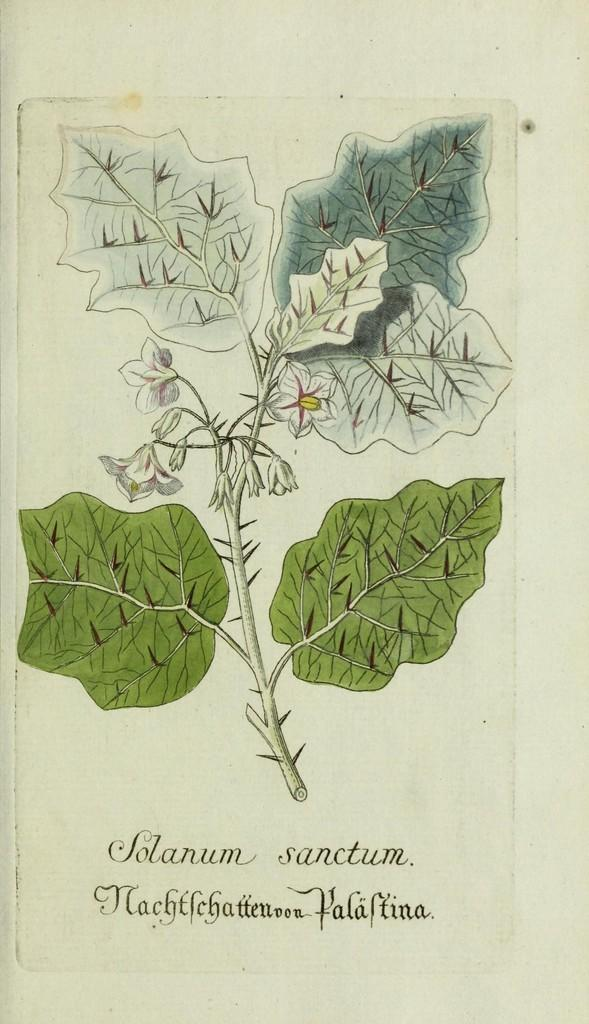What is featured on the poster in the image? The poster contains images of leaves and flowers. Is there any text on the poster? Yes, there is text on the poster. What type of badge is pinned to the throat of the person in the image? There is no person present in the image, and therefore no badge can be observed. 